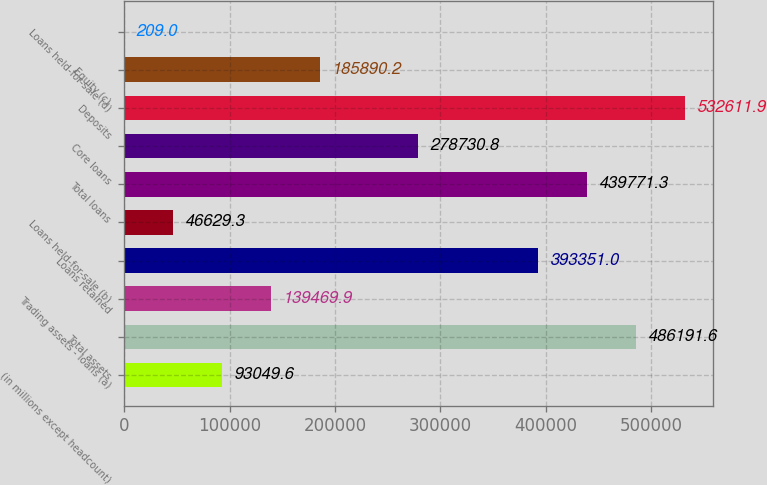<chart> <loc_0><loc_0><loc_500><loc_500><bar_chart><fcel>(in millions except headcount)<fcel>Total assets<fcel>Trading assets - loans (a)<fcel>Loans retained<fcel>Loans held-for-sale (b)<fcel>Total loans<fcel>Core loans<fcel>Deposits<fcel>Equity (c)<fcel>Loans held-for-sale (d)<nl><fcel>93049.6<fcel>486192<fcel>139470<fcel>393351<fcel>46629.3<fcel>439771<fcel>278731<fcel>532612<fcel>185890<fcel>209<nl></chart> 